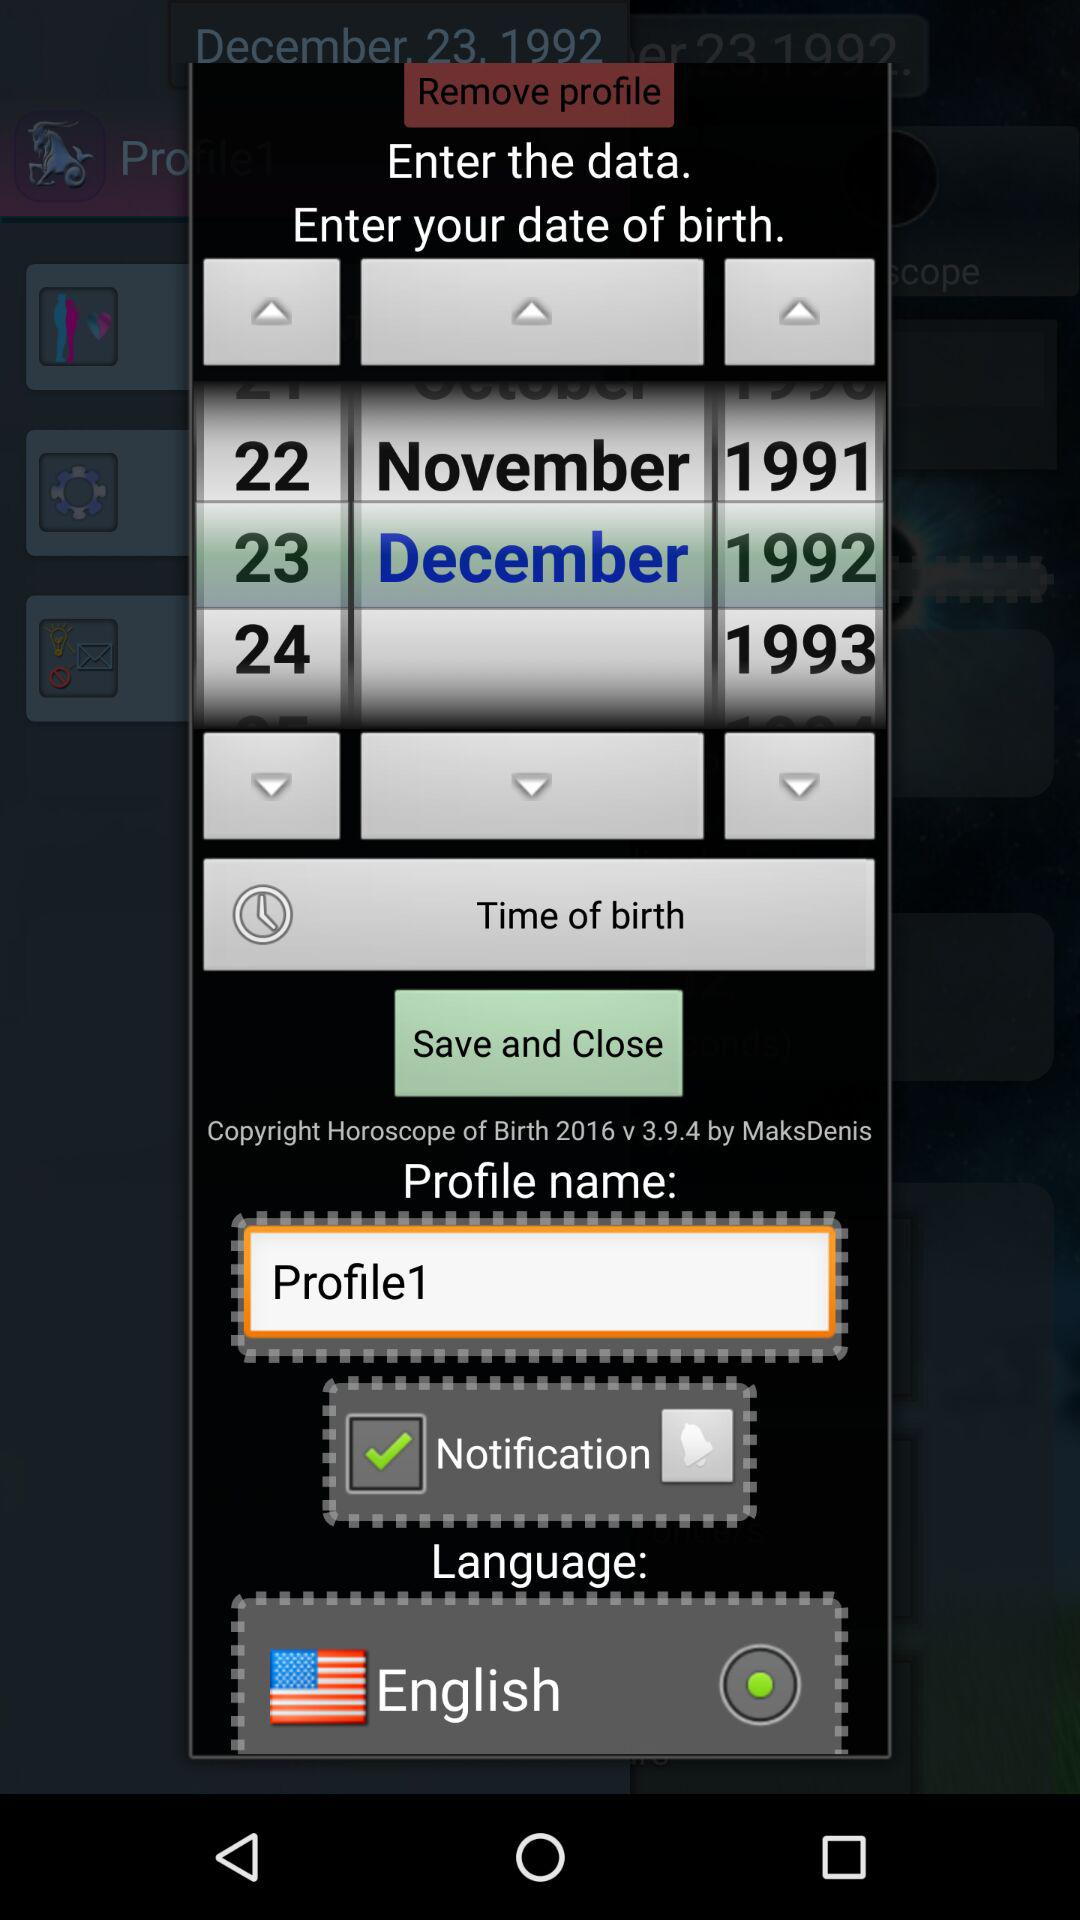What is the profile name? The profile name is "Profile1". 